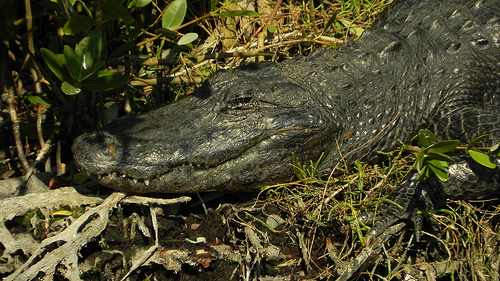<image>
Is the alligator under the leaf? Yes. The alligator is positioned underneath the leaf, with the leaf above it in the vertical space. 